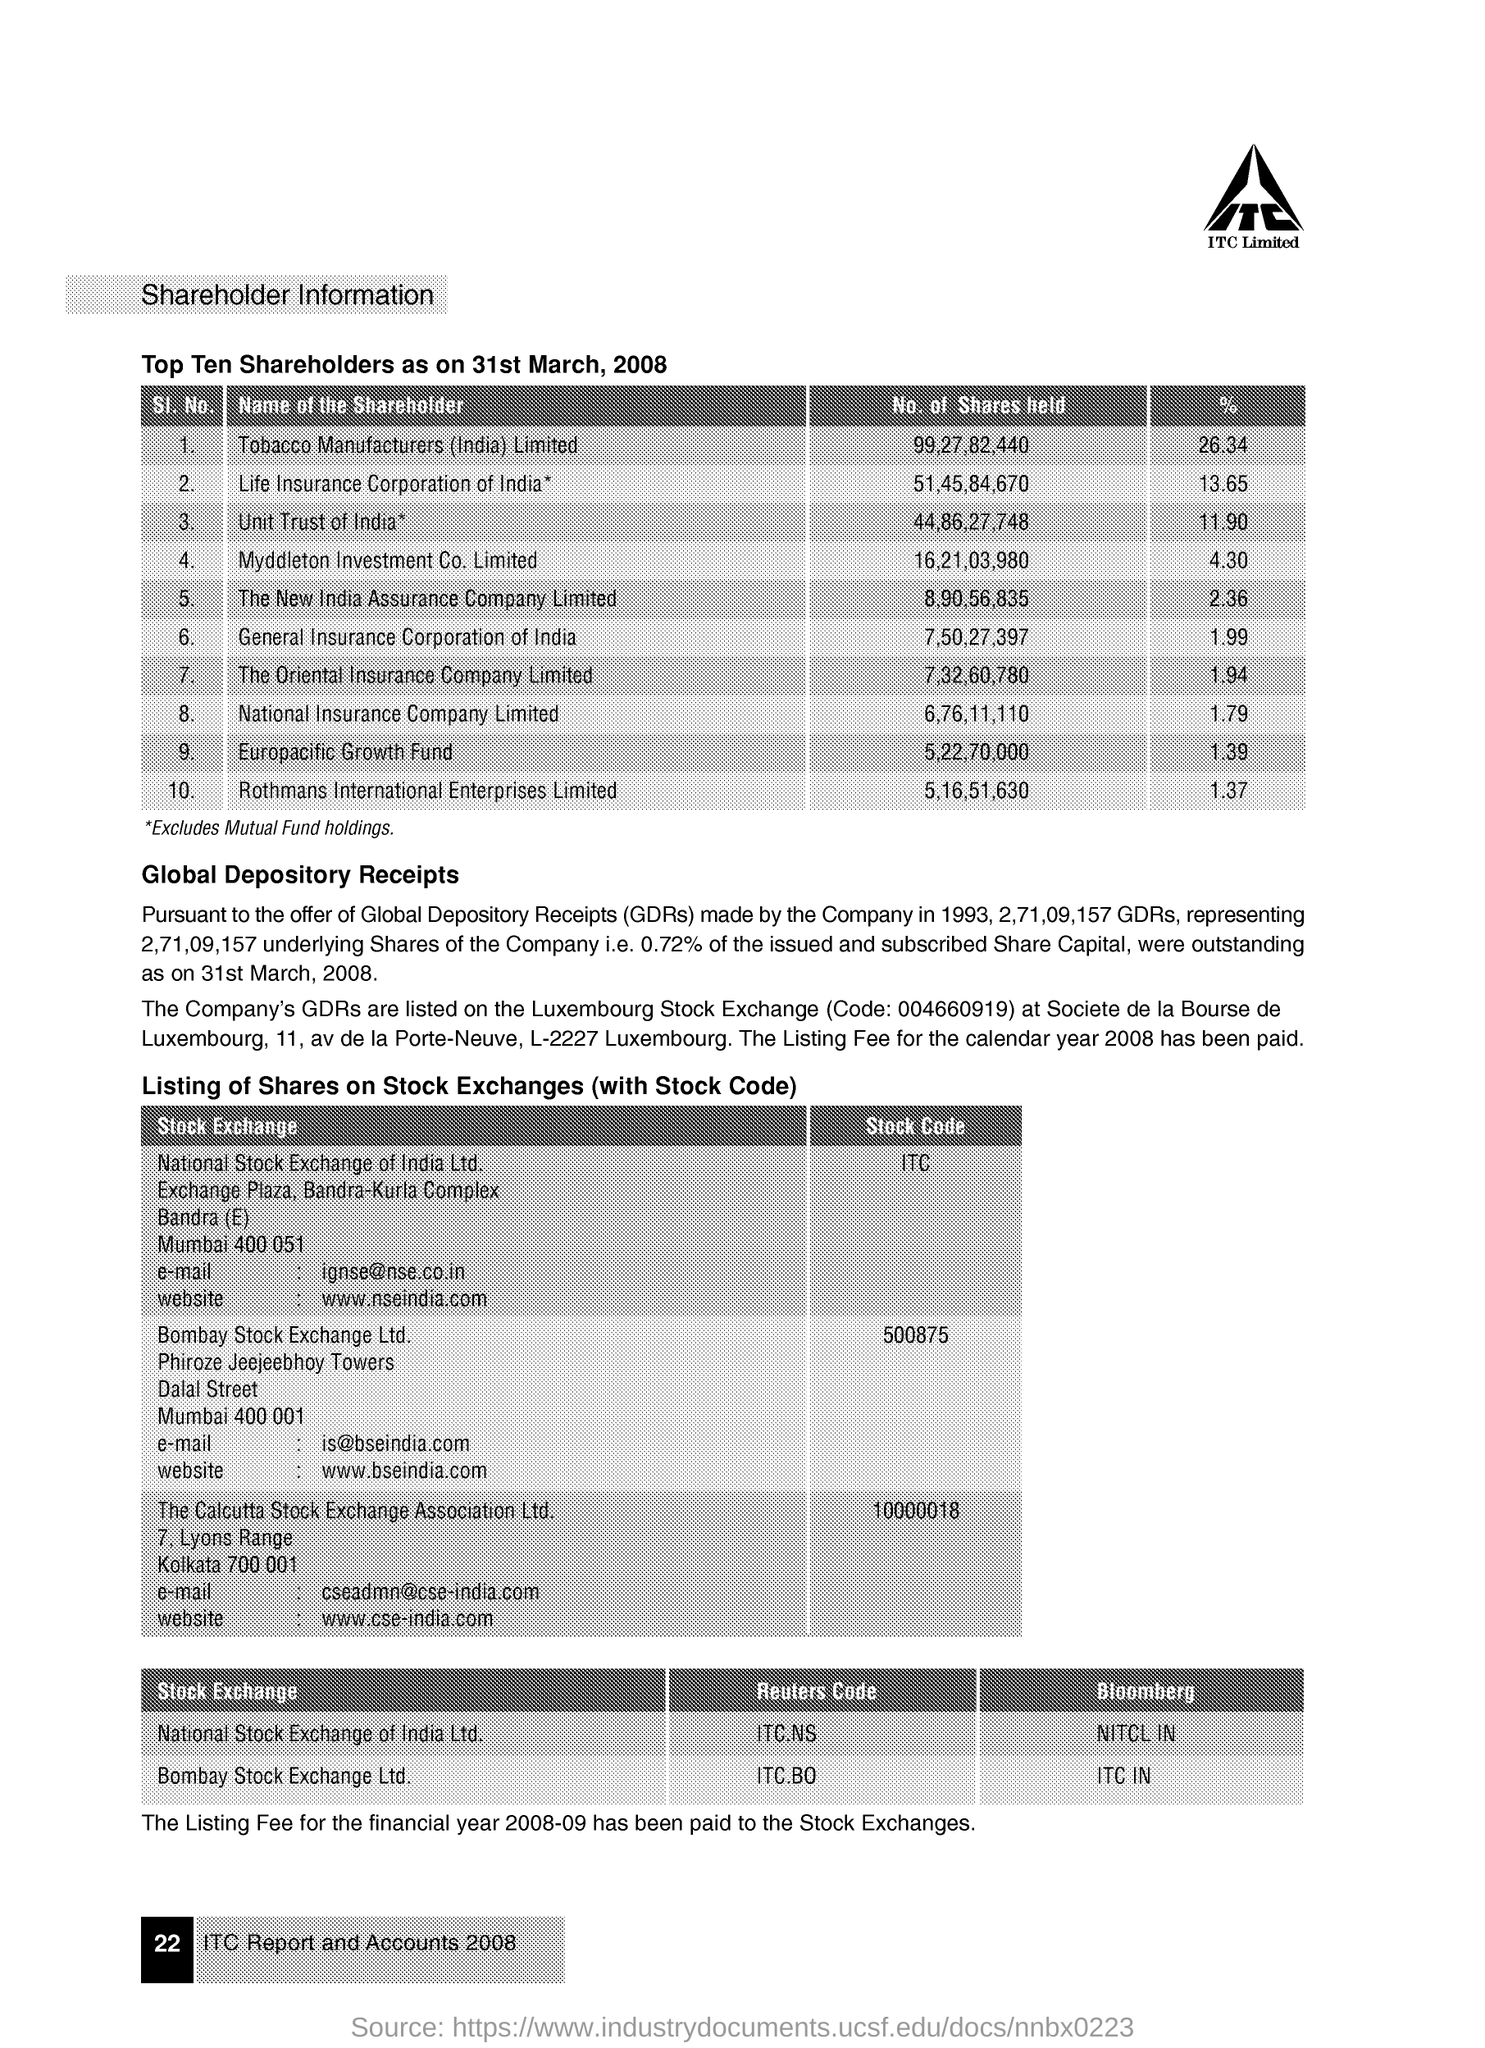Draw attention to some important aspects in this diagram. The Europacific Growth Fund holds a total of 5,227,000 shares. The stock code in Bombay Stock Exchange Ltd. is 500875. Tobacco Manufacturers (India) Limited held the highest percentage of shares as of March 31, 2008. National Insurance Company holds 1.79% of shares. The Reuters Code for the National Stock Exchange of India Ltd. is ITC.NS. 